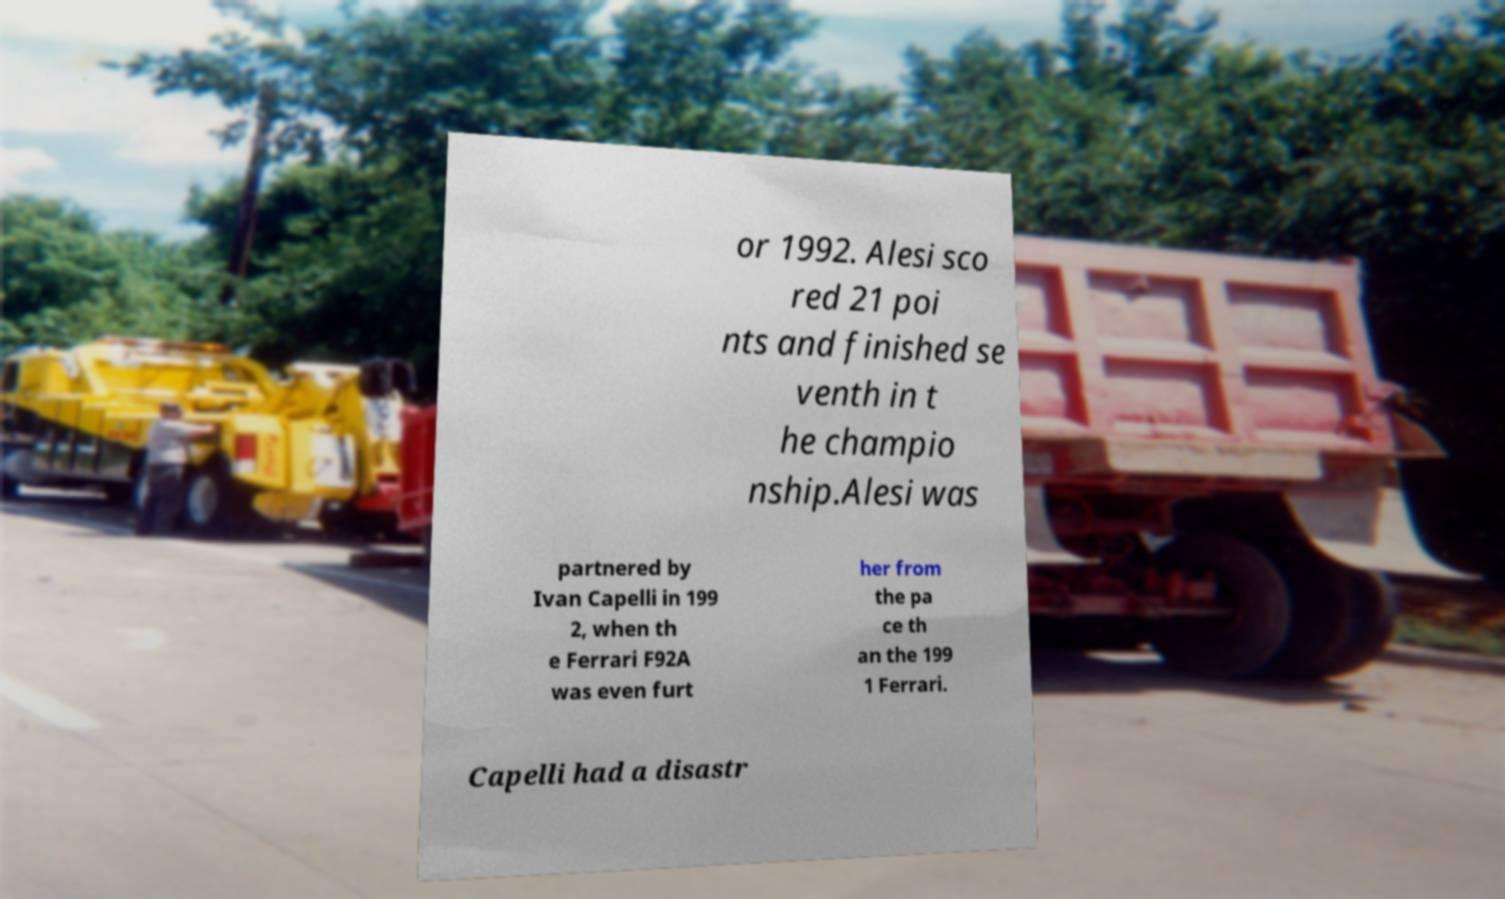Can you accurately transcribe the text from the provided image for me? or 1992. Alesi sco red 21 poi nts and finished se venth in t he champio nship.Alesi was partnered by Ivan Capelli in 199 2, when th e Ferrari F92A was even furt her from the pa ce th an the 199 1 Ferrari. Capelli had a disastr 